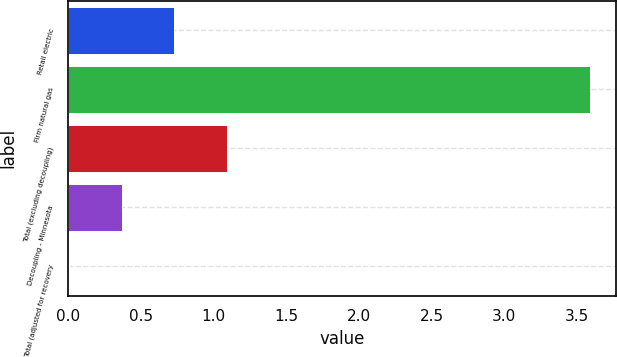<chart> <loc_0><loc_0><loc_500><loc_500><bar_chart><fcel>Retail electric<fcel>Firm natural gas<fcel>Total (excluding decoupling)<fcel>Decoupling - Minnesota<fcel>Total (adjusted for recovery<nl><fcel>0.73<fcel>3.59<fcel>1.09<fcel>0.37<fcel>0.01<nl></chart> 